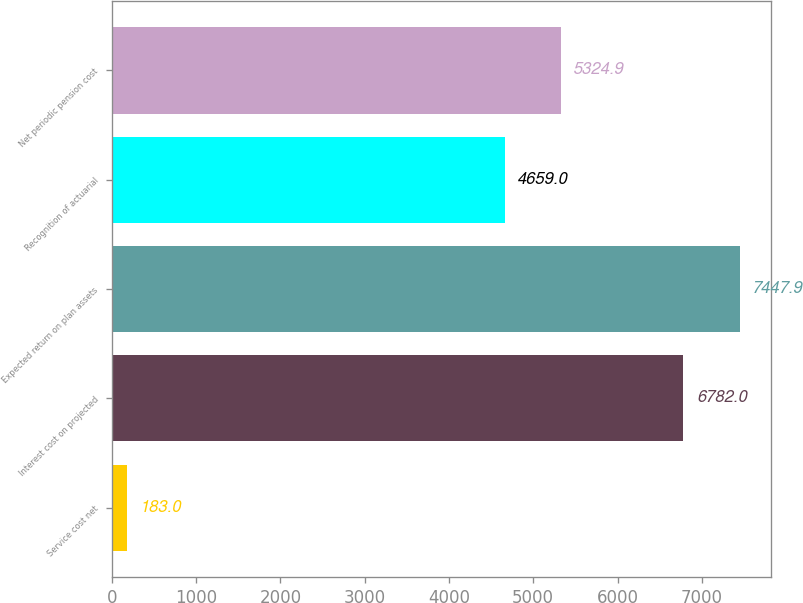<chart> <loc_0><loc_0><loc_500><loc_500><bar_chart><fcel>Service cost net<fcel>Interest cost on projected<fcel>Expected return on plan assets<fcel>Recognition of actuarial<fcel>Net periodic pension cost<nl><fcel>183<fcel>6782<fcel>7447.9<fcel>4659<fcel>5324.9<nl></chart> 